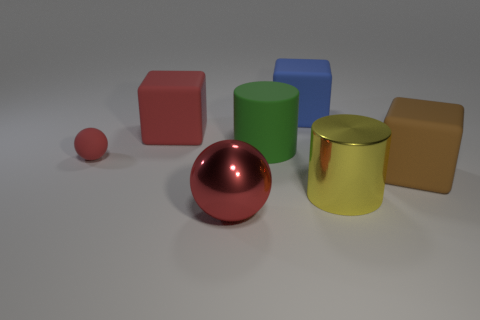Is the number of large blue objects less than the number of blocks?
Provide a succinct answer. Yes. What shape is the big rubber object that is behind the rubber block on the left side of the metal ball that is right of the big red rubber thing?
Offer a very short reply. Cube. How many objects are either large things that are behind the tiny matte ball or big red objects that are in front of the big brown cube?
Offer a very short reply. 4. There is a blue thing; are there any big cylinders behind it?
Make the answer very short. No. How many objects are blocks that are right of the large rubber cylinder or large red rubber cubes?
Make the answer very short. 3. How many yellow objects are large rubber cubes or cylinders?
Keep it short and to the point. 1. What number of other things are there of the same color as the small rubber sphere?
Give a very brief answer. 2. Is the number of yellow shiny cylinders in front of the yellow metal cylinder less than the number of red spheres?
Give a very brief answer. Yes. What color is the large block that is behind the cube that is left of the big blue object that is behind the red block?
Make the answer very short. Blue. What size is the matte thing that is the same shape as the big red shiny thing?
Offer a very short reply. Small. 